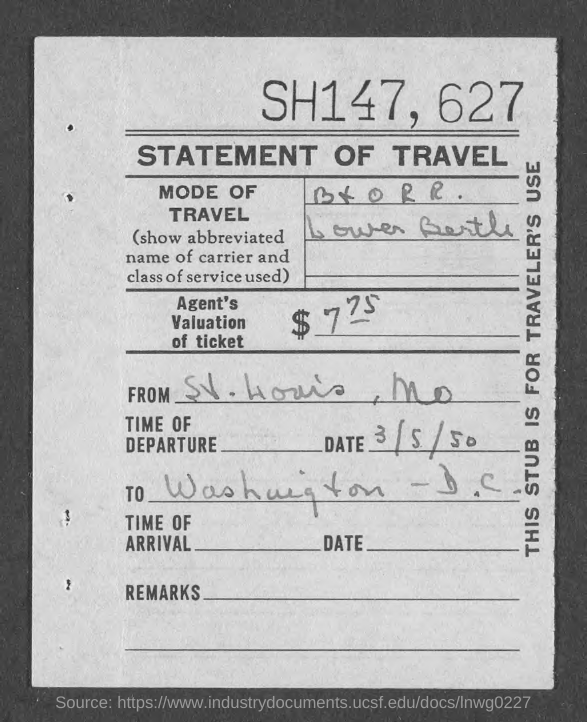What is the Title of the document?
Provide a short and direct response. STATEMENT OF TRAVEL. Where is it from?
Ensure brevity in your answer.  St. Louis, Mo. What is the date of departure?
Provide a short and direct response. 3/5/50. What is the stub for?
Your answer should be compact. TRAVELER'S USE. 